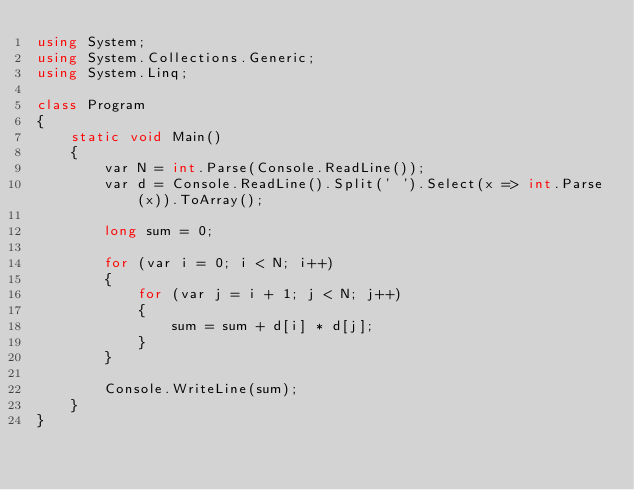<code> <loc_0><loc_0><loc_500><loc_500><_C#_>using System;
using System.Collections.Generic;
using System.Linq;

class Program
{
    static void Main()
    {
        var N = int.Parse(Console.ReadLine());
        var d = Console.ReadLine().Split(' ').Select(x => int.Parse(x)).ToArray();

        long sum = 0;

        for (var i = 0; i < N; i++)
        {
            for (var j = i + 1; j < N; j++)
            {
                sum = sum + d[i] * d[j];
            }
        }

        Console.WriteLine(sum);
    }
}
</code> 